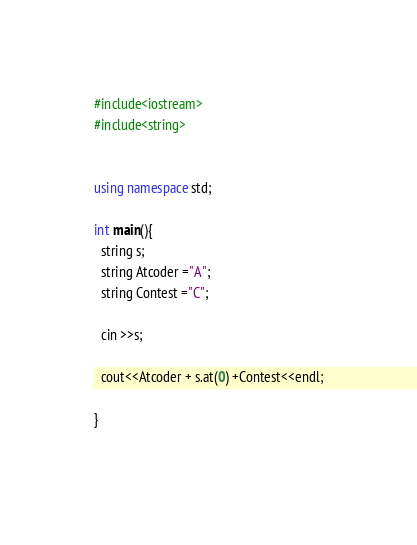Convert code to text. <code><loc_0><loc_0><loc_500><loc_500><_C++_>#include<iostream>
#include<string>


using namespace std;

int main(){
  string s;
  string Atcoder ="A";
  string Contest ="C";

  cin >>s;
  
  cout<<Atcoder + s.at(0) +Contest<<endl;

}
  </code> 